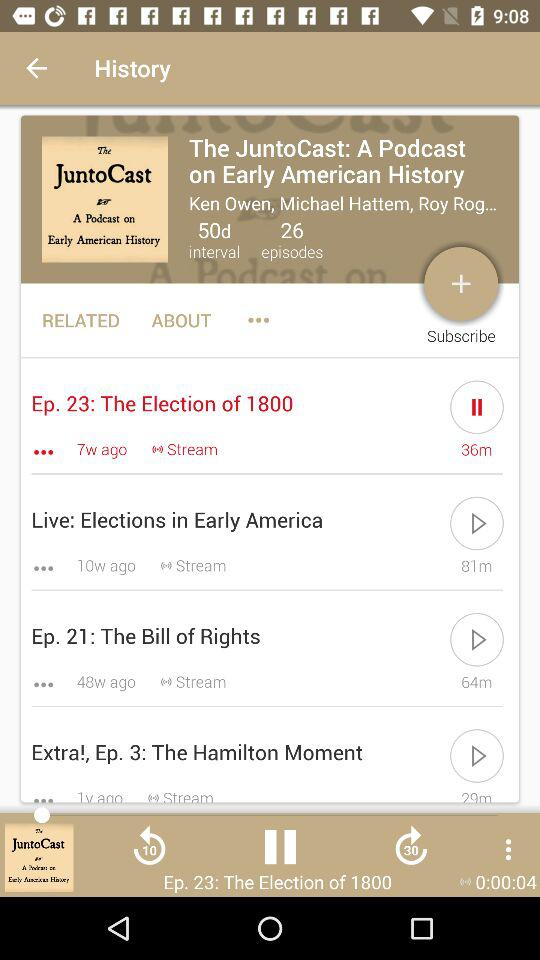How many episodes are there in total?
Answer the question using a single word or phrase. 4 